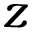Convert formula to latex. <formula><loc_0><loc_0><loc_500><loc_500>z</formula> 